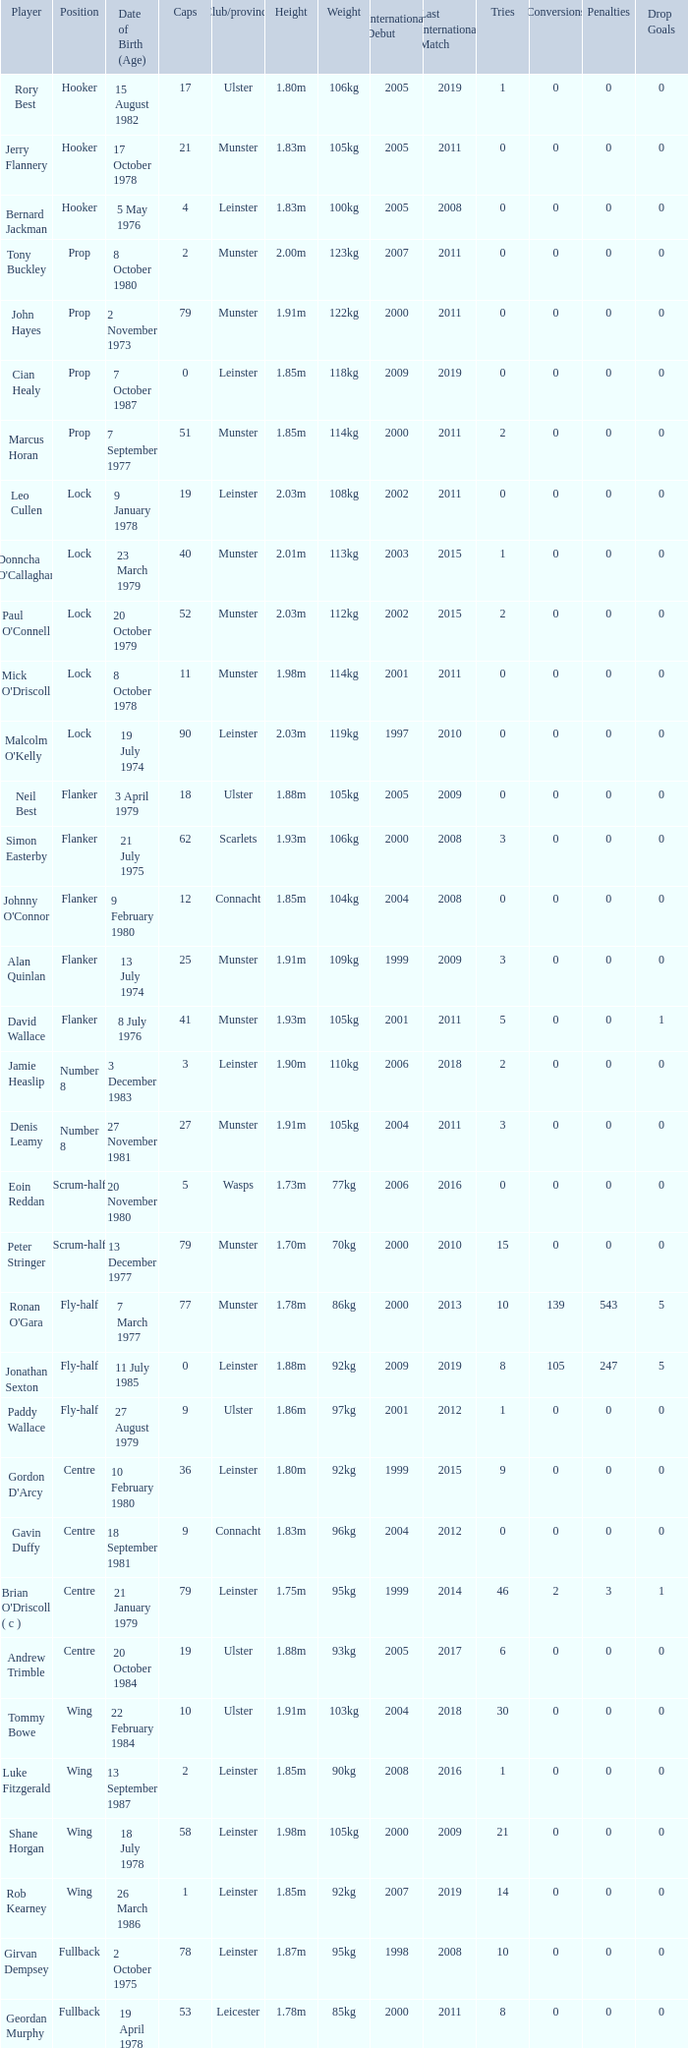What Club/province have caps less than 2 and Jonathan Sexton as player? Leinster. Write the full table. {'header': ['Player', 'Position', 'Date of Birth (Age)', 'Caps', 'Club/province', 'Height', 'Weight', 'International Debut', 'Last International Match', 'Tries', 'Conversions', 'Penalties', 'Drop Goals'], 'rows': [['Rory Best', 'Hooker', '15 August 1982', '17', 'Ulster', '1.80m', '106kg', '2005', '2019', '1', '0', '0', '0'], ['Jerry Flannery', 'Hooker', '17 October 1978', '21', 'Munster', '1.83m', '105kg', '2005', '2011', '0', '0', '0', '0'], ['Bernard Jackman', 'Hooker', '5 May 1976', '4', 'Leinster', '1.83m', '100kg', '2005', '2008', '0', '0', '0', '0'], ['Tony Buckley', 'Prop', '8 October 1980', '2', 'Munster', '2.00m', '123kg', '2007', '2011', '0', '0', '0', '0'], ['John Hayes', 'Prop', '2 November 1973', '79', 'Munster', '1.91m', '122kg', '2000', '2011', '0', '0', '0', '0'], ['Cian Healy', 'Prop', '7 October 1987', '0', 'Leinster', '1.85m', '118kg', '2009', '2019', '0', '0', '0', '0'], ['Marcus Horan', 'Prop', '7 September 1977', '51', 'Munster', '1.85m', '114kg', '2000', '2011', '2', '0', '0', '0'], ['Leo Cullen', 'Lock', '9 January 1978', '19', 'Leinster', '2.03m', '108kg', '2002', '2011', '0', '0', '0', '0'], ["Donncha O'Callaghan", 'Lock', '23 March 1979', '40', 'Munster', '2.01m', '113kg', '2003', '2015', '1', '0', '0', '0'], ["Paul O'Connell", 'Lock', '20 October 1979', '52', 'Munster', '2.03m', '112kg', '2002', '2015', '2', '0', '0', '0'], ["Mick O'Driscoll", 'Lock', '8 October 1978', '11', 'Munster', '1.98m', '114kg', '2001', '2011', '0', '0', '0', '0'], ["Malcolm O'Kelly", 'Lock', '19 July 1974', '90', 'Leinster', '2.03m', '119kg', '1997', '2010', '0', '0', '0', '0'], ['Neil Best', 'Flanker', '3 April 1979', '18', 'Ulster', '1.88m', '105kg', '2005', '2009', '0', '0', '0', '0'], ['Simon Easterby', 'Flanker', '21 July 1975', '62', 'Scarlets', '1.93m', '106kg', '2000', '2008', '3', '0', '0', '0'], ["Johnny O'Connor", 'Flanker', '9 February 1980', '12', 'Connacht', '1.85m', '104kg', '2004', '2008', '0', '0', '0', '0'], ['Alan Quinlan', 'Flanker', '13 July 1974', '25', 'Munster', '1.91m', '109kg', '1999', '2009', '3', '0', '0', '0'], ['David Wallace', 'Flanker', '8 July 1976', '41', 'Munster', '1.93m', '105kg', '2001', '2011', '5', '0', '0', '1'], ['Jamie Heaslip', 'Number 8', '3 December 1983', '3', 'Leinster', '1.90m', '110kg', '2006', '2018', '2', '0', '0', '0'], ['Denis Leamy', 'Number 8', '27 November 1981', '27', 'Munster', '1.91m', '105kg', '2004', '2011', '3', '0', '0', '0'], ['Eoin Reddan', 'Scrum-half', '20 November 1980', '5', 'Wasps', '1.73m', '77kg', '2006', '2016', '0', '0', '0', '0'], ['Peter Stringer', 'Scrum-half', '13 December 1977', '79', 'Munster', '1.70m', '70kg', '2000', '2010', '15', '0', '0', '0'], ["Ronan O'Gara", 'Fly-half', '7 March 1977', '77', 'Munster', '1.78m', '86kg', '2000', '2013', '10', '139', '543', '5'], ['Jonathan Sexton', 'Fly-half', '11 July 1985', '0', 'Leinster', '1.88m', '92kg', '2009', '2019', '8', '105', '247', '5'], ['Paddy Wallace', 'Fly-half', '27 August 1979', '9', 'Ulster', '1.86m', '97kg', '2001', '2012', '1', '0', '0', '0'], ["Gordon D'Arcy", 'Centre', '10 February 1980', '36', 'Leinster', '1.80m', '92kg', '1999', '2015', '9', '0', '0', '0'], ['Gavin Duffy', 'Centre', '18 September 1981', '9', 'Connacht', '1.83m', '96kg', '2004', '2012', '0', '0', '0', '0'], ["Brian O'Driscoll ( c )", 'Centre', '21 January 1979', '79', 'Leinster', '1.75m', '95kg', '1999', '2014', '46', '2', '3', '1'], ['Andrew Trimble', 'Centre', '20 October 1984', '19', 'Ulster', '1.88m', '93kg', '2005', '2017', '6', '0', '0', '0'], ['Tommy Bowe', 'Wing', '22 February 1984', '10', 'Ulster', '1.91m', '103kg', '2004', '2018', '30', '0', '0', '0'], ['Luke Fitzgerald', 'Wing', '13 September 1987', '2', 'Leinster', '1.85m', '90kg', '2008', '2016', '1', '0', '0', '0'], ['Shane Horgan', 'Wing', '18 July 1978', '58', 'Leinster', '1.98m', '105kg', '2000', '2009', '21', '0', '0', '0'], ['Rob Kearney', 'Wing', '26 March 1986', '1', 'Leinster', '1.85m', '92kg', '2007', '2019', '14', '0', '0', '0'], ['Girvan Dempsey', 'Fullback', '2 October 1975', '78', 'Leinster', '1.87m', '95kg', '1998', '2008', '10', '0', '0', '0'], ['Geordan Murphy', 'Fullback', '19 April 1978', '53', 'Leicester', '1.78m', '85kg', '2000', '2011', '8', '0', '0', '0']]} 